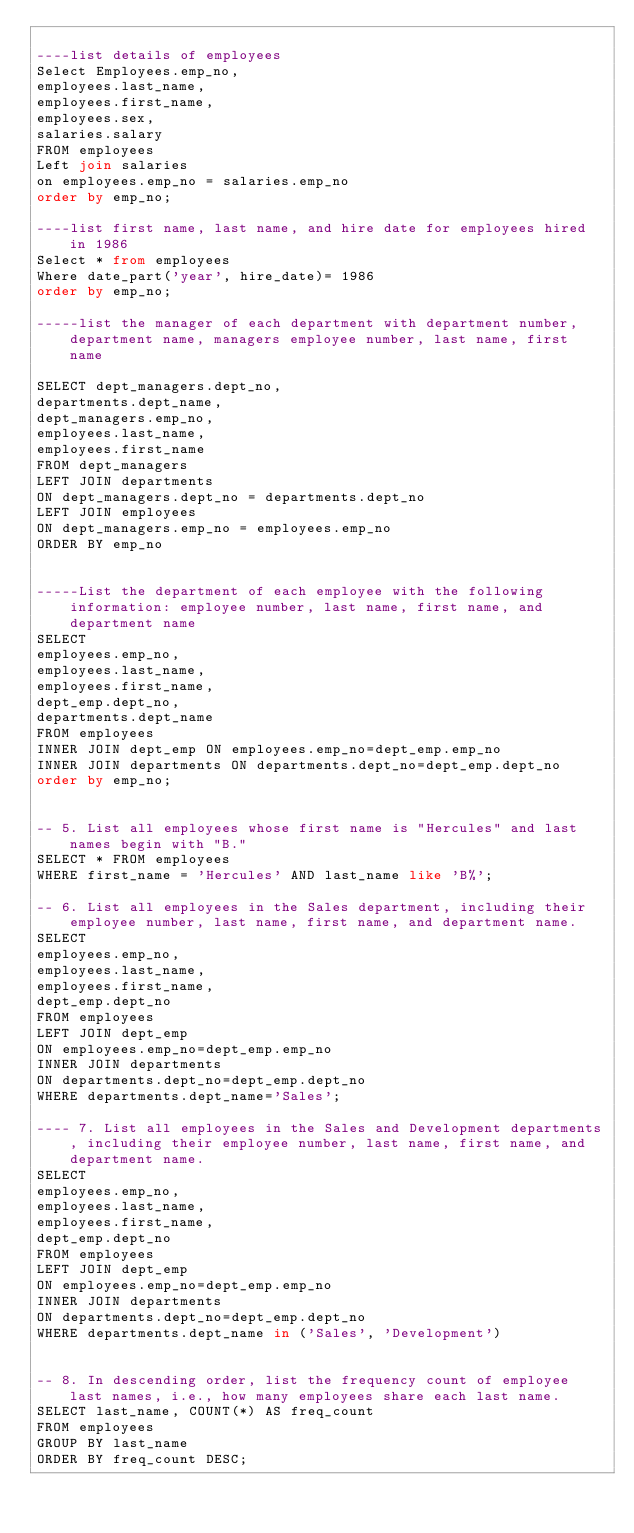<code> <loc_0><loc_0><loc_500><loc_500><_SQL_>
----list details of employees
Select Employees.emp_no,
employees.last_name,
employees.first_name,
employees.sex,
salaries.salary
FROM employees
Left join salaries
on employees.emp_no = salaries.emp_no
order by emp_no;

----list first name, last name, and hire date for employees hired in 1986
Select * from employees
Where date_part('year', hire_date)= 1986
order by emp_no;

-----list the manager of each department with department number, department name, managers employee number, last name, first name

SELECT dept_managers.dept_no, 
departments.dept_name,
dept_managers.emp_no,
employees.last_name, 
employees.first_name
FROM dept_managers
LEFT JOIN departments
ON dept_managers.dept_no = departments.dept_no
LEFT JOIN employees 
ON dept_managers.emp_no = employees.emp_no
ORDER BY emp_no


-----List the department of each employee with the following information: employee number, last name, first name, and department name
SELECT
employees.emp_no,
employees.last_name,
employees.first_name,
dept_emp.dept_no,
departments.dept_name
FROM employees 
INNER JOIN dept_emp ON employees.emp_no=dept_emp.emp_no
INNER JOIN departments ON departments.dept_no=dept_emp.dept_no
order by emp_no;


-- 5. List all employees whose first name is "Hercules" and last names begin with "B."
SELECT * FROM employees
WHERE first_name = 'Hercules' AND last_name like 'B%';

-- 6. List all employees in the Sales department, including their employee number, last name, first name, and department name.
SELECT 
employees.emp_no, 
employees.last_name, 
employees.first_name,
dept_emp.dept_no
FROM employees 
LEFT JOIN dept_emp 
ON employees.emp_no=dept_emp.emp_no
INNER JOIN departments 
ON departments.dept_no=dept_emp.dept_no
WHERE departments.dept_name='Sales';

---- 7. List all employees in the Sales and Development departments, including their employee number, last name, first name, and department name.
SELECT 
employees.emp_no, 
employees.last_name, 
employees.first_name,
dept_emp.dept_no
FROM employees 
LEFT JOIN dept_emp 
ON employees.emp_no=dept_emp.emp_no
INNER JOIN departments 
ON departments.dept_no=dept_emp.dept_no
WHERE departments.dept_name in ('Sales', 'Development')


-- 8. In descending order, list the frequency count of employee last names, i.e., how many employees share each last name.
SELECT last_name, COUNT(*) AS freq_count
FROM employees
GROUP BY last_name
ORDER BY freq_count DESC;</code> 